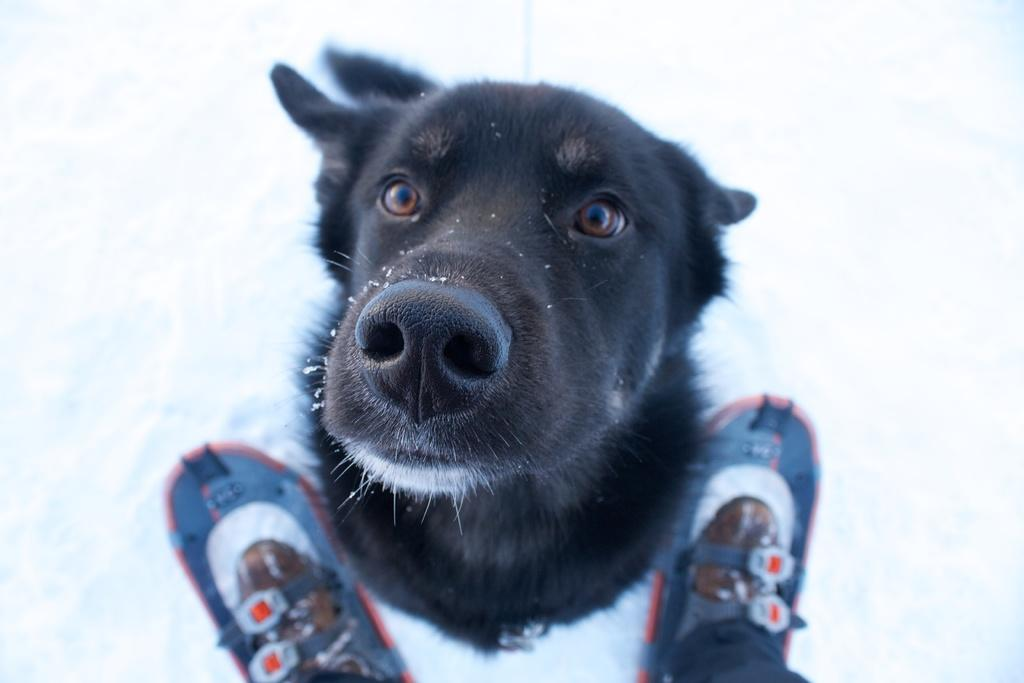What type of animal is in the image? There is a black dog in the image. What else can be seen in the image besides the dog? There are shoes in the image. What is the setting of the image? The image shows snow. How many snails can be seen crawling on the dog in the image? There are no snails present in the image; it features a black dog in the snow. What type of cloth is used to cover the dog in the image? There is no cloth covering the dog in the image; it is a black dog in the snow with no additional coverings. 